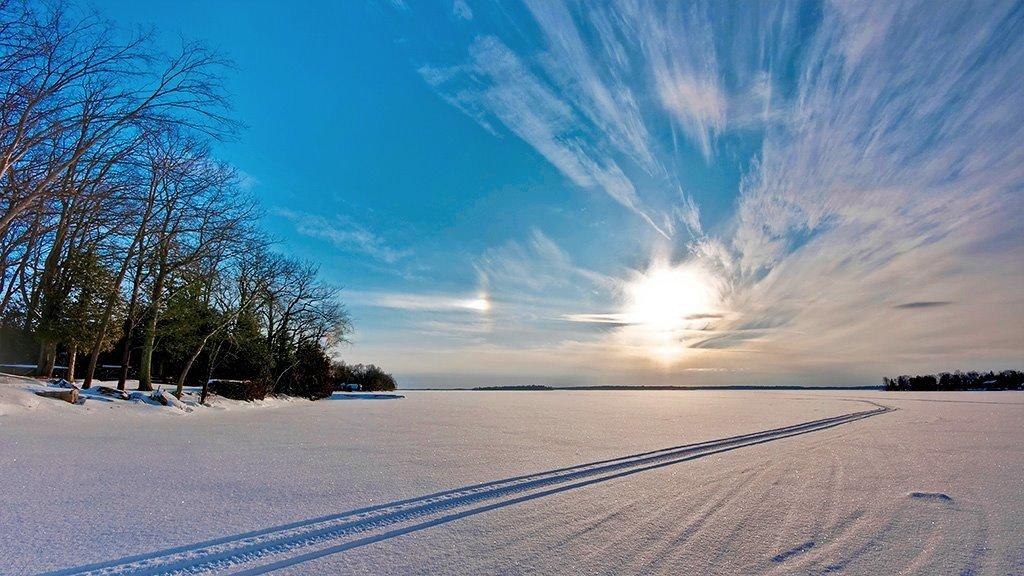What is present at the bottom of the image? There is snow at the bottom of the image. What can be seen in the middle of the image? There are trees in the middle of the image. What is visible at the top of the image? There are clouds and the sun visible in the sky at the top of the image. What type of scarf is being used to measure the pleasure in the image? There is no scarf or measurement of pleasure present in the image. How many drops of water can be seen falling from the clouds in the image? There are no drops of water visible in the image; only clouds and the sun are present in the sky. 